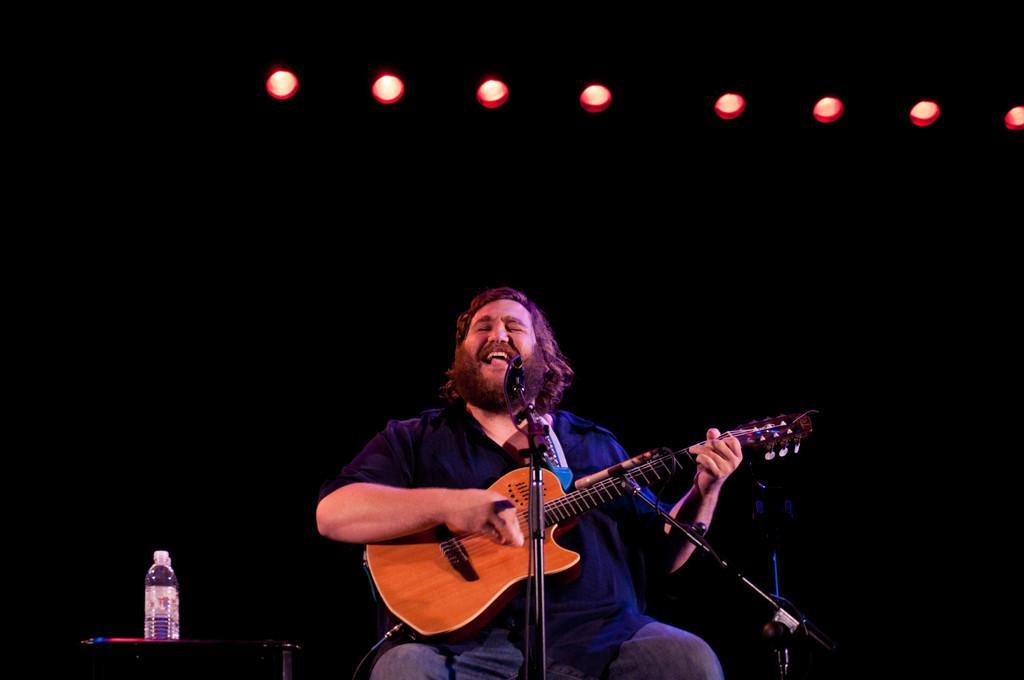Please provide a concise description of this image. In the image we can see there is a person who is sitting and holding guitar in his hand and there is mic with a stand and on table there are water bottles. 